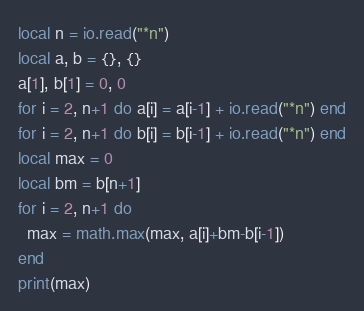Convert code to text. <code><loc_0><loc_0><loc_500><loc_500><_Lua_>local n = io.read("*n")
local a, b = {}, {}
a[1], b[1] = 0, 0
for i = 2, n+1 do a[i] = a[i-1] + io.read("*n") end
for i = 2, n+1 do b[i] = b[i-1] + io.read("*n") end
local max = 0
local bm = b[n+1]
for i = 2, n+1 do
  max = math.max(max, a[i]+bm-b[i-1])
end
print(max)
</code> 